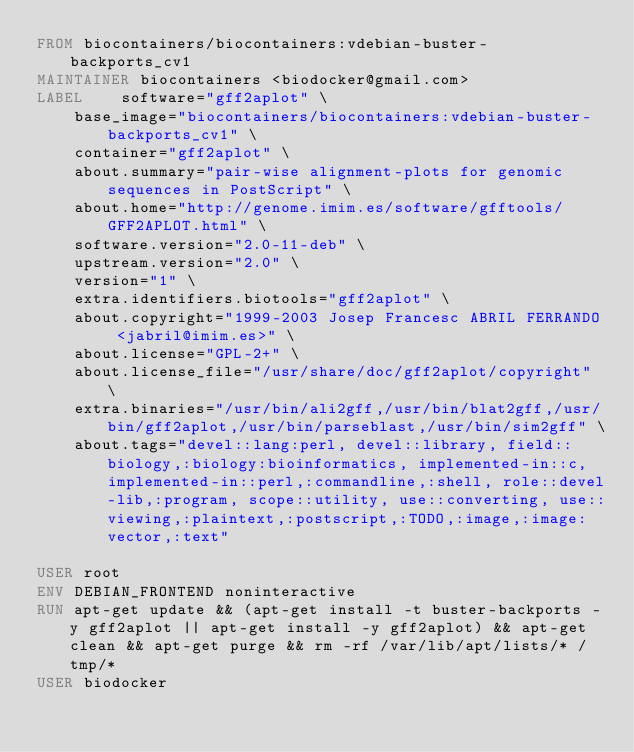Convert code to text. <code><loc_0><loc_0><loc_500><loc_500><_Dockerfile_>FROM biocontainers/biocontainers:vdebian-buster-backports_cv1
MAINTAINER biocontainers <biodocker@gmail.com>
LABEL    software="gff2aplot" \ 
    base_image="biocontainers/biocontainers:vdebian-buster-backports_cv1" \ 
    container="gff2aplot" \ 
    about.summary="pair-wise alignment-plots for genomic sequences in PostScript" \ 
    about.home="http://genome.imim.es/software/gfftools/GFF2APLOT.html" \ 
    software.version="2.0-11-deb" \ 
    upstream.version="2.0" \ 
    version="1" \ 
    extra.identifiers.biotools="gff2aplot" \ 
    about.copyright="1999-2003 Josep Francesc ABRIL FERRANDO <jabril@imim.es>" \ 
    about.license="GPL-2+" \ 
    about.license_file="/usr/share/doc/gff2aplot/copyright" \ 
    extra.binaries="/usr/bin/ali2gff,/usr/bin/blat2gff,/usr/bin/gff2aplot,/usr/bin/parseblast,/usr/bin/sim2gff" \ 
    about.tags="devel::lang:perl, devel::library, field::biology,:biology:bioinformatics, implemented-in::c, implemented-in::perl,:commandline,:shell, role::devel-lib,:program, scope::utility, use::converting, use::viewing,:plaintext,:postscript,:TODO,:image,:image:vector,:text" 

USER root
ENV DEBIAN_FRONTEND noninteractive
RUN apt-get update && (apt-get install -t buster-backports -y gff2aplot || apt-get install -y gff2aplot) && apt-get clean && apt-get purge && rm -rf /var/lib/apt/lists/* /tmp/*
USER biodocker
</code> 